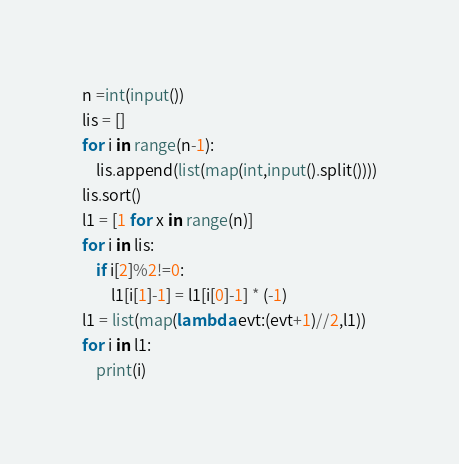<code> <loc_0><loc_0><loc_500><loc_500><_Python_>n =int(input())
lis = []
for i in range(n-1):
    lis.append(list(map(int,input().split())))
lis.sort()
l1 = [1 for x in range(n)]
for i in lis:
    if i[2]%2!=0:
        l1[i[1]-1] = l1[i[0]-1] * (-1)
l1 = list(map(lambda evt:(evt+1)//2,l1))
for i in l1:
    print(i)
</code> 